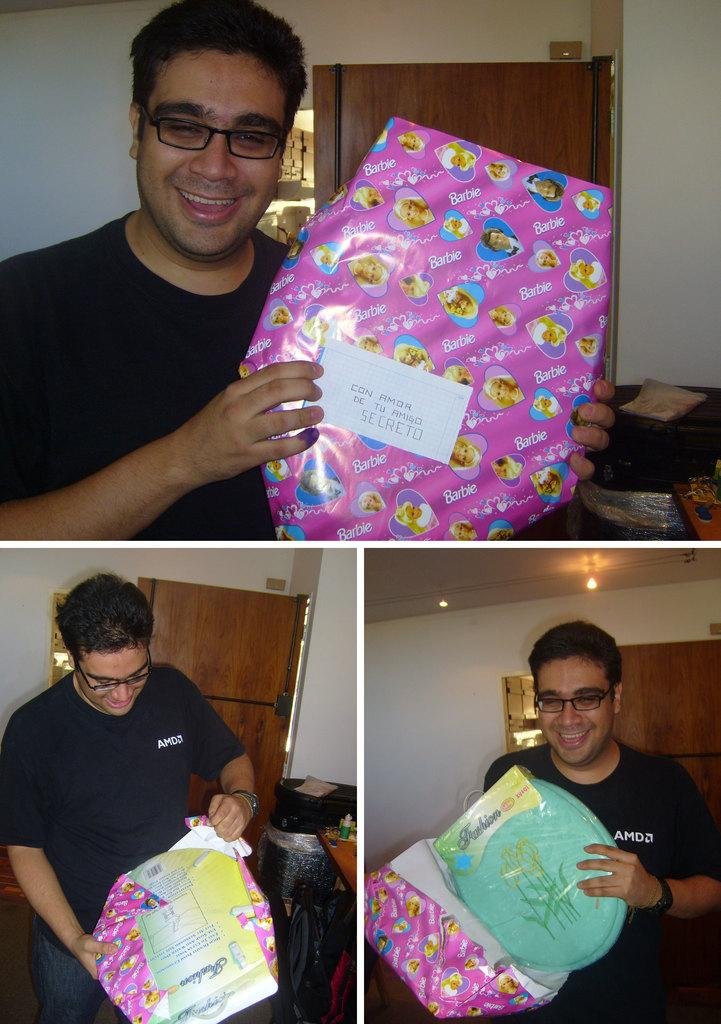What is the composition of the image? The image is a collage of three different pictures. Who is the subject of the pictures in the collage? All three pictures depict the same person. What is the person doing in each picture? The person is holding a package in each picture. How is the person holding the package? The person is using their hands to hold the package. What type of soda can be seen in the image? There is no soda present in the image; it features a person holding packages in each picture. Is the person driving a car in any of the pictures? No, the person is not driving a car in any of the pictures; they are holding packages. 